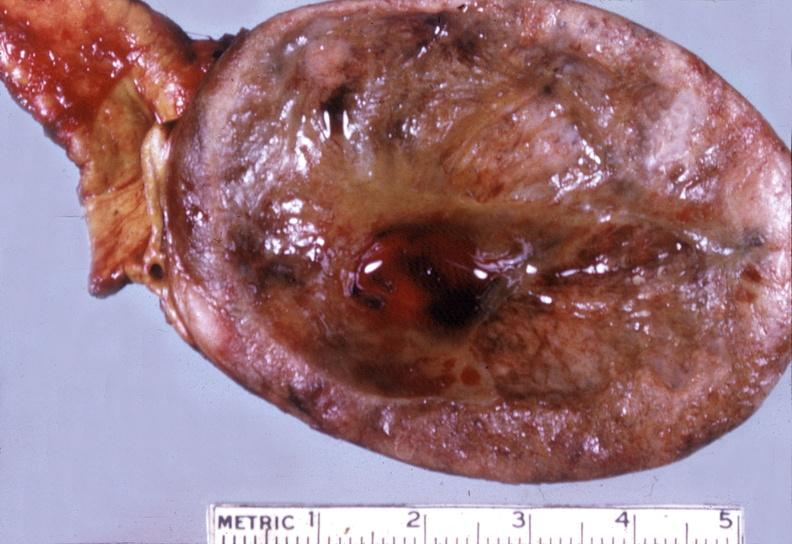s omentum present?
Answer the question using a single word or phrase. No 